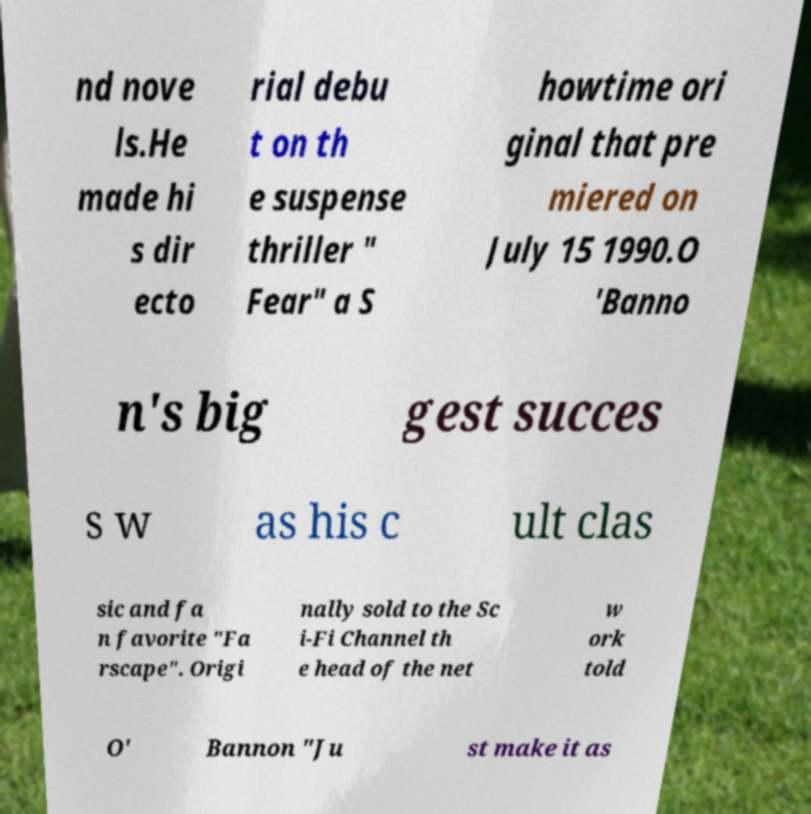I need the written content from this picture converted into text. Can you do that? nd nove ls.He made hi s dir ecto rial debu t on th e suspense thriller " Fear" a S howtime ori ginal that pre miered on July 15 1990.O 'Banno n's big gest succes s w as his c ult clas sic and fa n favorite "Fa rscape". Origi nally sold to the Sc i-Fi Channel th e head of the net w ork told O' Bannon "Ju st make it as 